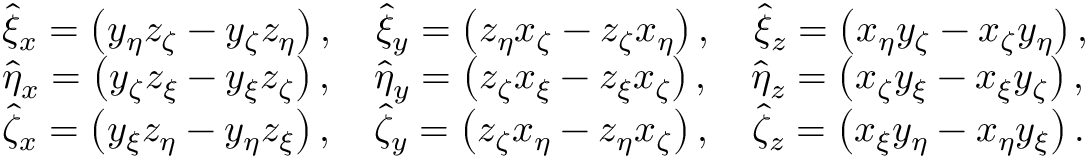<formula> <loc_0><loc_0><loc_500><loc_500>\begin{array} { r l } & { \hat { \xi } _ { x } = \left ( y _ { \eta } z _ { \zeta } - y _ { \zeta } z _ { \eta } \right ) , \quad \hat { \xi } _ { y } = \left ( z _ { \eta } x _ { \zeta } - z _ { \zeta } x _ { \eta } \right ) , \quad \hat { \xi } _ { z } = \left ( x _ { \eta } y _ { \zeta } - x _ { \zeta } y _ { \eta } \right ) , } \\ & { \hat { \eta } _ { x } = \left ( y _ { \zeta } z _ { \xi } - y _ { \xi } z _ { \zeta } \right ) , \quad \hat { \eta } _ { y } = \left ( z _ { \zeta } x _ { \xi } - z _ { \xi } x _ { \zeta } \right ) , \quad \hat { \eta } _ { z } = \left ( x _ { \zeta } y _ { \xi } - x _ { \xi } y _ { \zeta } \right ) , } \\ & { \hat { \zeta } _ { x } = \left ( y _ { \xi } z _ { \eta } - y _ { \eta } z _ { \xi } \right ) , \quad \hat { \zeta } _ { y } = \left ( z _ { \zeta } x _ { \eta } - z _ { \eta } x _ { \zeta } \right ) , \quad \hat { \zeta } _ { z } = \left ( x _ { \xi } y _ { \eta } - x _ { \eta } y _ { \xi } \right ) . } \end{array}</formula> 